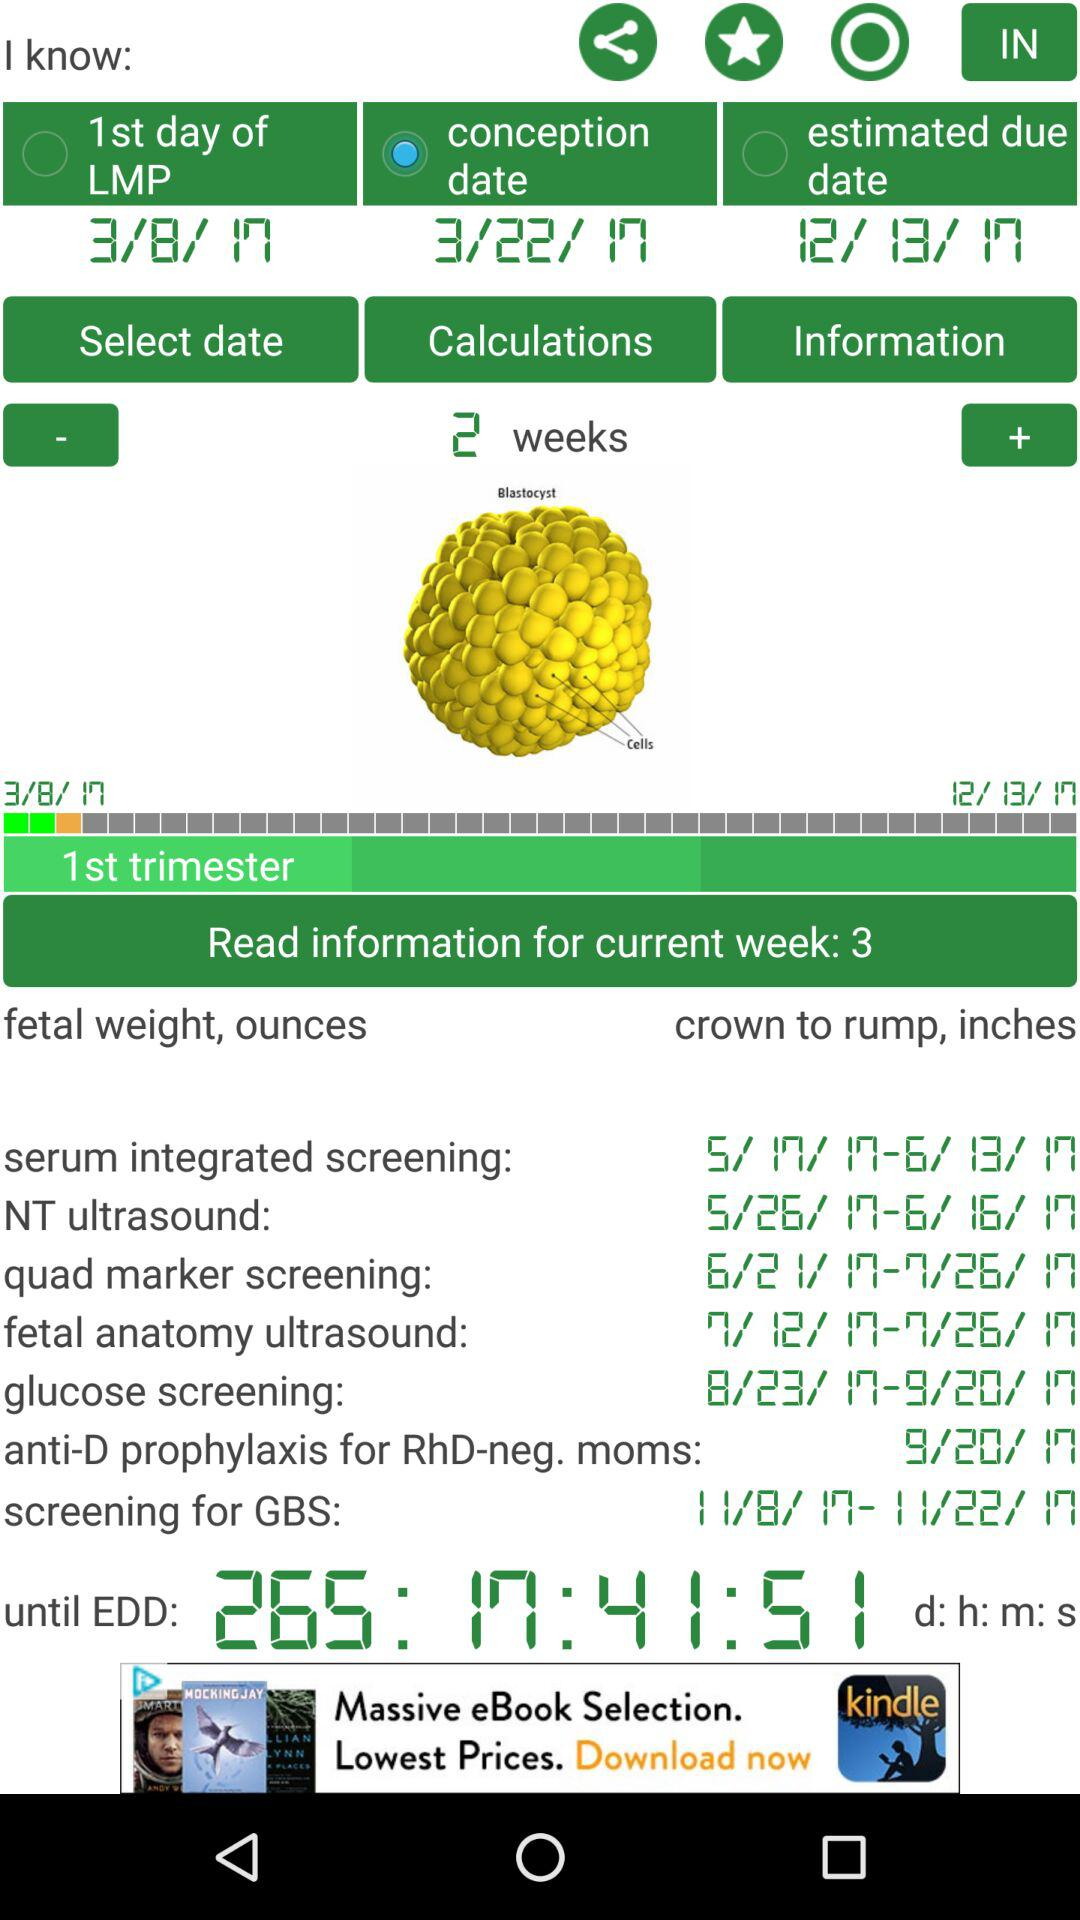What date is the first day of LMP? The first day of LMP is on March 8, 2017. 